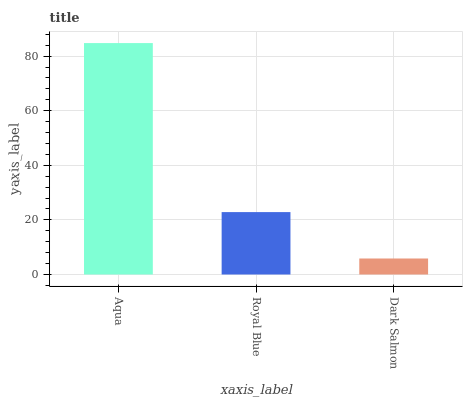Is Royal Blue the minimum?
Answer yes or no. No. Is Royal Blue the maximum?
Answer yes or no. No. Is Aqua greater than Royal Blue?
Answer yes or no. Yes. Is Royal Blue less than Aqua?
Answer yes or no. Yes. Is Royal Blue greater than Aqua?
Answer yes or no. No. Is Aqua less than Royal Blue?
Answer yes or no. No. Is Royal Blue the high median?
Answer yes or no. Yes. Is Royal Blue the low median?
Answer yes or no. Yes. Is Dark Salmon the high median?
Answer yes or no. No. Is Aqua the low median?
Answer yes or no. No. 